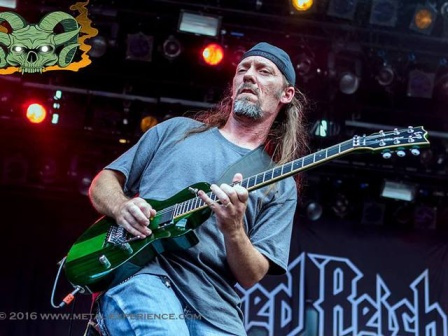Can you describe the musician's style and what it might say about his musical influences? The musician’s style, characterized by his casual gray t-shirt and black bandana, suggests a laid-back yet rebellious rock persona. The vibrant green guitar hints at a preference for standing out and possibly a penchant for progressive or alternative rock genres. His intense focus and the overall stage setup point towards influences from classic rock bands that emphasize showmanship and powerful performances. What could the green skull graphic symbolize in this context? The green skull graphic likely adds a touch of edginess and a hint of dark, perhaps rebellious, undertones to the performance. It could symbolize themes of life and death often explored in rock and metal music, suggesting that the band might delve into deeper, grittier themes or simply use it to create a memorable visual impact. Imagine a backstory for this musician. How did he get to this stage performance? Growing up in a small town where rock music was the lifeblood of the community, this musician was captivated by the powerful riffs and heartfelt lyrics of legendary rock bands. He spent years honing his skills, practicing in his garage and playing at local venues. His dedication paid off when he formed a band with fellow passionate musicians. They spent countless hours composing original music and performing at local clubs.

Their big break came when they impressed a talent scout at a regional music festival. Soon after, they were signed by an indie label, leading to their first major performance at 'Red Beach', where this photo was taken. The black banner behind him symbolizes their breakthrough moment, a testament to his journey from a passionate amateur to a stage-commanding rockstar. 